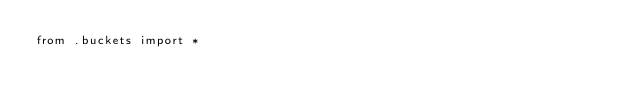Convert code to text. <code><loc_0><loc_0><loc_500><loc_500><_Python_>from .buckets import *
</code> 